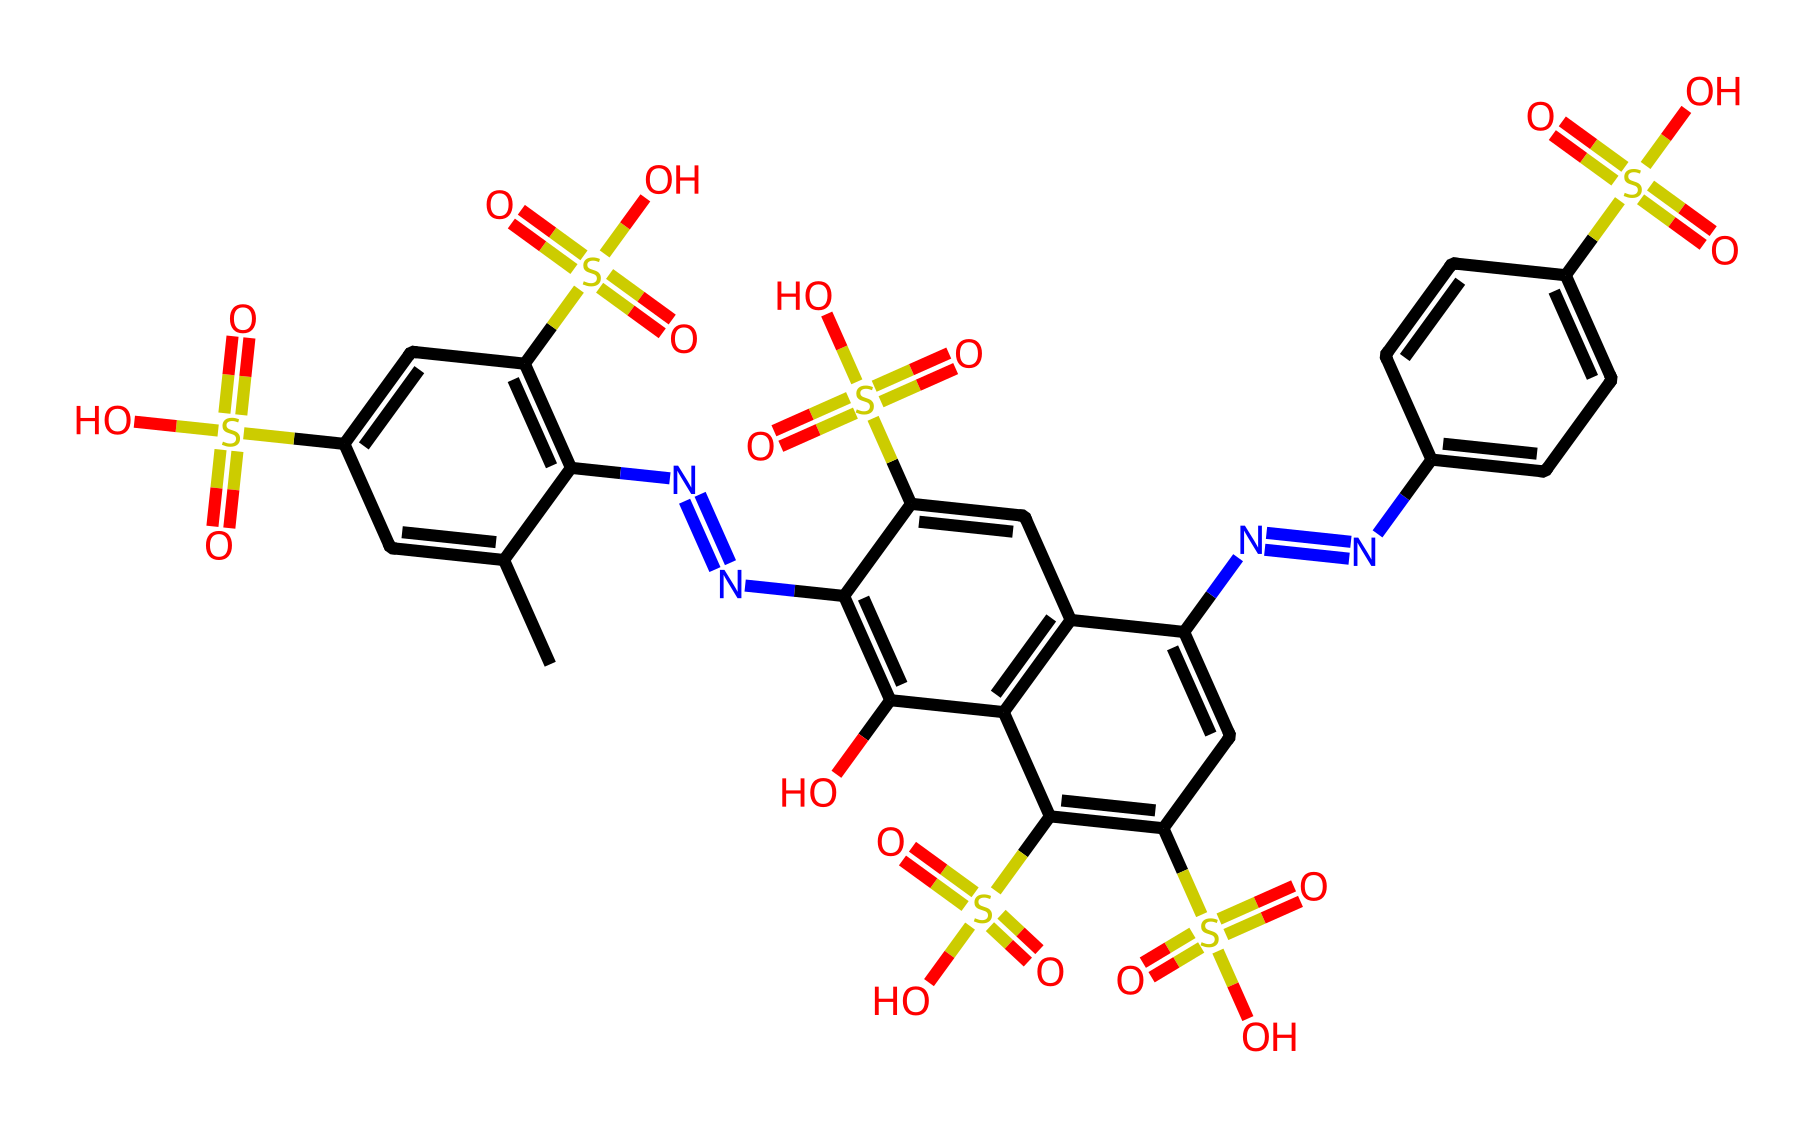What is the total number of carbon atoms in this structure? By examining the SMILES representation, you can identify each carbon symbol (C) in the chain. Counting all the carbon atoms present gives a total of 20 carbon atoms.
Answer: 20 How many nitrogen atoms are present in this dye? In the given SMILES, you can find nitrogen atoms represented by the symbol (N). Counting each nitrogen in the structure leads to a total of 4 nitrogen atoms.
Answer: 4 What is the primary functional group featured in this dye? The presence of sulfonic acid groups is indicated by the (S(=O)(=O)O) structure, which is repeated multiple times in the molecule. Thus, the primary functional group is sulfonic acid.
Answer: sulfonic acid How many sulfonic acid groups are there in this chemical? By analyzing the structure carefully, we can see that the sulfonic acid functional group appears five times throughout the molecule. Therefore, there are a total of 5 sulfonic acid groups.
Answer: 5 Is this compound likely to be soluble in water? The presence of multiple sulfonic acid groups, which are polar and hydrophilic, suggests that this dye is likely to be soluble in water, as these groups enhance water solubility.
Answer: yes What type of dye is represented here based on its reactive groups? This structure has reactive nitrogen atoms and sulfonic acid groups that are characteristic of reactive dyes, which are used for covalent bonding to fabrics for colorfastness. Thus, the dye is a reactive dye.
Answer: reactive dye 